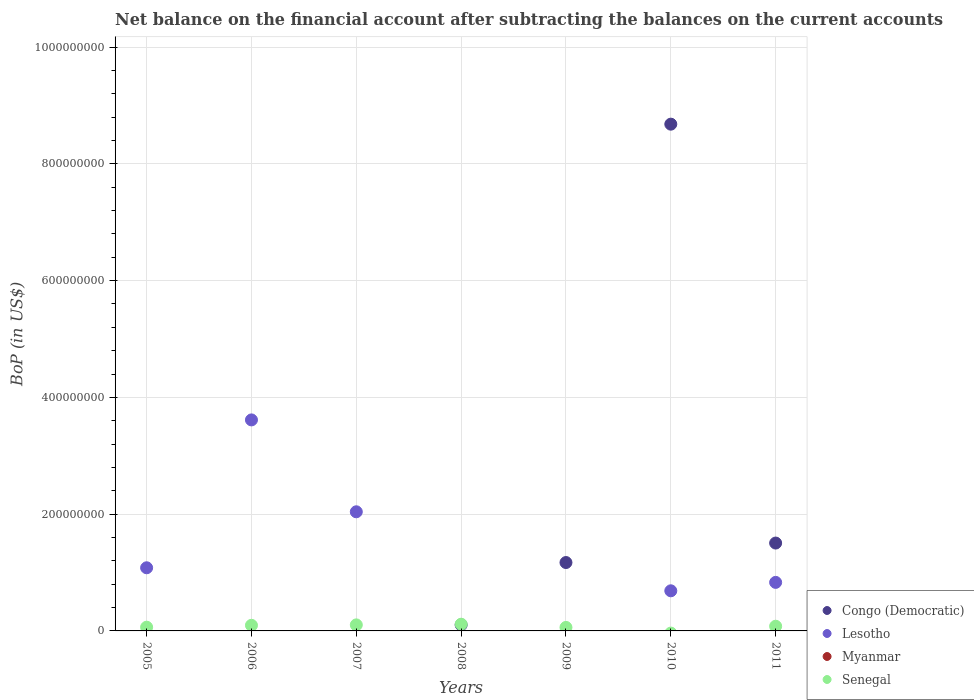How many different coloured dotlines are there?
Give a very brief answer. 3. Is the number of dotlines equal to the number of legend labels?
Your response must be concise. No. What is the Balance of Payments in Myanmar in 2008?
Offer a terse response. 0. Across all years, what is the maximum Balance of Payments in Senegal?
Provide a short and direct response. 1.15e+07. Across all years, what is the minimum Balance of Payments in Congo (Democratic)?
Keep it short and to the point. 0. In which year was the Balance of Payments in Congo (Democratic) maximum?
Provide a short and direct response. 2010. What is the total Balance of Payments in Myanmar in the graph?
Your response must be concise. 0. What is the difference between the Balance of Payments in Senegal in 2006 and that in 2011?
Your answer should be very brief. 1.59e+06. What is the difference between the Balance of Payments in Lesotho in 2011 and the Balance of Payments in Myanmar in 2009?
Offer a very short reply. 8.31e+07. What is the average Balance of Payments in Senegal per year?
Ensure brevity in your answer.  7.41e+06. In the year 2009, what is the difference between the Balance of Payments in Senegal and Balance of Payments in Congo (Democratic)?
Your answer should be very brief. -1.11e+08. In how many years, is the Balance of Payments in Congo (Democratic) greater than 400000000 US$?
Provide a succinct answer. 1. What is the difference between the highest and the second highest Balance of Payments in Senegal?
Provide a succinct answer. 1.15e+06. What is the difference between the highest and the lowest Balance of Payments in Senegal?
Ensure brevity in your answer.  1.15e+07. In how many years, is the Balance of Payments in Myanmar greater than the average Balance of Payments in Myanmar taken over all years?
Offer a terse response. 0. Is the sum of the Balance of Payments in Lesotho in 2007 and 2010 greater than the maximum Balance of Payments in Myanmar across all years?
Keep it short and to the point. Yes. Is the Balance of Payments in Lesotho strictly greater than the Balance of Payments in Myanmar over the years?
Your answer should be very brief. Yes. How many dotlines are there?
Provide a succinct answer. 3. How many years are there in the graph?
Offer a very short reply. 7. What is the difference between two consecutive major ticks on the Y-axis?
Give a very brief answer. 2.00e+08. What is the title of the graph?
Your answer should be compact. Net balance on the financial account after subtracting the balances on the current accounts. What is the label or title of the Y-axis?
Your response must be concise. BoP (in US$). What is the BoP (in US$) of Congo (Democratic) in 2005?
Give a very brief answer. 0. What is the BoP (in US$) of Lesotho in 2005?
Ensure brevity in your answer.  1.08e+08. What is the BoP (in US$) of Myanmar in 2005?
Make the answer very short. 0. What is the BoP (in US$) in Senegal in 2005?
Ensure brevity in your answer.  6.39e+06. What is the BoP (in US$) of Congo (Democratic) in 2006?
Give a very brief answer. 0. What is the BoP (in US$) in Lesotho in 2006?
Provide a short and direct response. 3.61e+08. What is the BoP (in US$) of Myanmar in 2006?
Your answer should be very brief. 0. What is the BoP (in US$) of Senegal in 2006?
Your answer should be compact. 9.62e+06. What is the BoP (in US$) in Lesotho in 2007?
Your response must be concise. 2.04e+08. What is the BoP (in US$) of Myanmar in 2007?
Make the answer very short. 0. What is the BoP (in US$) of Senegal in 2007?
Offer a very short reply. 1.03e+07. What is the BoP (in US$) of Congo (Democratic) in 2008?
Your answer should be very brief. 1.03e+07. What is the BoP (in US$) in Myanmar in 2008?
Your response must be concise. 0. What is the BoP (in US$) in Senegal in 2008?
Your answer should be compact. 1.15e+07. What is the BoP (in US$) in Congo (Democratic) in 2009?
Provide a short and direct response. 1.17e+08. What is the BoP (in US$) in Lesotho in 2009?
Keep it short and to the point. 0. What is the BoP (in US$) of Senegal in 2009?
Give a very brief answer. 5.99e+06. What is the BoP (in US$) of Congo (Democratic) in 2010?
Provide a succinct answer. 8.68e+08. What is the BoP (in US$) in Lesotho in 2010?
Provide a short and direct response. 6.87e+07. What is the BoP (in US$) in Myanmar in 2010?
Your answer should be very brief. 0. What is the BoP (in US$) of Senegal in 2010?
Offer a very short reply. 0. What is the BoP (in US$) in Congo (Democratic) in 2011?
Provide a succinct answer. 1.50e+08. What is the BoP (in US$) in Lesotho in 2011?
Your answer should be very brief. 8.31e+07. What is the BoP (in US$) of Senegal in 2011?
Your answer should be very brief. 8.03e+06. Across all years, what is the maximum BoP (in US$) in Congo (Democratic)?
Provide a succinct answer. 8.68e+08. Across all years, what is the maximum BoP (in US$) in Lesotho?
Your response must be concise. 3.61e+08. Across all years, what is the maximum BoP (in US$) of Senegal?
Your answer should be very brief. 1.15e+07. Across all years, what is the minimum BoP (in US$) in Lesotho?
Your answer should be very brief. 0. What is the total BoP (in US$) of Congo (Democratic) in the graph?
Offer a terse response. 1.15e+09. What is the total BoP (in US$) of Lesotho in the graph?
Your response must be concise. 8.25e+08. What is the total BoP (in US$) in Myanmar in the graph?
Offer a terse response. 0. What is the total BoP (in US$) in Senegal in the graph?
Provide a succinct answer. 5.19e+07. What is the difference between the BoP (in US$) of Lesotho in 2005 and that in 2006?
Your answer should be compact. -2.53e+08. What is the difference between the BoP (in US$) of Senegal in 2005 and that in 2006?
Your response must be concise. -3.23e+06. What is the difference between the BoP (in US$) in Lesotho in 2005 and that in 2007?
Provide a short and direct response. -9.59e+07. What is the difference between the BoP (in US$) in Senegal in 2005 and that in 2007?
Make the answer very short. -3.96e+06. What is the difference between the BoP (in US$) of Senegal in 2005 and that in 2008?
Make the answer very short. -5.11e+06. What is the difference between the BoP (in US$) of Senegal in 2005 and that in 2009?
Keep it short and to the point. 3.96e+05. What is the difference between the BoP (in US$) in Lesotho in 2005 and that in 2010?
Provide a short and direct response. 3.94e+07. What is the difference between the BoP (in US$) of Lesotho in 2005 and that in 2011?
Provide a short and direct response. 2.50e+07. What is the difference between the BoP (in US$) in Senegal in 2005 and that in 2011?
Offer a very short reply. -1.64e+06. What is the difference between the BoP (in US$) in Lesotho in 2006 and that in 2007?
Offer a terse response. 1.57e+08. What is the difference between the BoP (in US$) in Senegal in 2006 and that in 2007?
Offer a terse response. -7.30e+05. What is the difference between the BoP (in US$) in Senegal in 2006 and that in 2008?
Offer a very short reply. -1.88e+06. What is the difference between the BoP (in US$) in Senegal in 2006 and that in 2009?
Make the answer very short. 3.63e+06. What is the difference between the BoP (in US$) in Lesotho in 2006 and that in 2010?
Your answer should be very brief. 2.93e+08. What is the difference between the BoP (in US$) of Lesotho in 2006 and that in 2011?
Your response must be concise. 2.78e+08. What is the difference between the BoP (in US$) of Senegal in 2006 and that in 2011?
Offer a very short reply. 1.59e+06. What is the difference between the BoP (in US$) in Senegal in 2007 and that in 2008?
Ensure brevity in your answer.  -1.15e+06. What is the difference between the BoP (in US$) of Senegal in 2007 and that in 2009?
Ensure brevity in your answer.  4.36e+06. What is the difference between the BoP (in US$) in Lesotho in 2007 and that in 2010?
Keep it short and to the point. 1.35e+08. What is the difference between the BoP (in US$) in Lesotho in 2007 and that in 2011?
Ensure brevity in your answer.  1.21e+08. What is the difference between the BoP (in US$) of Senegal in 2007 and that in 2011?
Keep it short and to the point. 2.32e+06. What is the difference between the BoP (in US$) of Congo (Democratic) in 2008 and that in 2009?
Keep it short and to the point. -1.07e+08. What is the difference between the BoP (in US$) in Senegal in 2008 and that in 2009?
Your response must be concise. 5.51e+06. What is the difference between the BoP (in US$) of Congo (Democratic) in 2008 and that in 2010?
Give a very brief answer. -8.58e+08. What is the difference between the BoP (in US$) in Congo (Democratic) in 2008 and that in 2011?
Your answer should be very brief. -1.40e+08. What is the difference between the BoP (in US$) of Senegal in 2008 and that in 2011?
Your answer should be very brief. 3.47e+06. What is the difference between the BoP (in US$) in Congo (Democratic) in 2009 and that in 2010?
Provide a succinct answer. -7.51e+08. What is the difference between the BoP (in US$) in Congo (Democratic) in 2009 and that in 2011?
Your answer should be very brief. -3.34e+07. What is the difference between the BoP (in US$) of Senegal in 2009 and that in 2011?
Give a very brief answer. -2.04e+06. What is the difference between the BoP (in US$) in Congo (Democratic) in 2010 and that in 2011?
Give a very brief answer. 7.17e+08. What is the difference between the BoP (in US$) in Lesotho in 2010 and that in 2011?
Provide a short and direct response. -1.44e+07. What is the difference between the BoP (in US$) in Lesotho in 2005 and the BoP (in US$) in Senegal in 2006?
Give a very brief answer. 9.85e+07. What is the difference between the BoP (in US$) in Lesotho in 2005 and the BoP (in US$) in Senegal in 2007?
Offer a very short reply. 9.78e+07. What is the difference between the BoP (in US$) in Lesotho in 2005 and the BoP (in US$) in Senegal in 2008?
Provide a short and direct response. 9.66e+07. What is the difference between the BoP (in US$) of Lesotho in 2005 and the BoP (in US$) of Senegal in 2009?
Offer a terse response. 1.02e+08. What is the difference between the BoP (in US$) in Lesotho in 2005 and the BoP (in US$) in Senegal in 2011?
Make the answer very short. 1.00e+08. What is the difference between the BoP (in US$) in Lesotho in 2006 and the BoP (in US$) in Senegal in 2007?
Provide a succinct answer. 3.51e+08. What is the difference between the BoP (in US$) of Lesotho in 2006 and the BoP (in US$) of Senegal in 2008?
Keep it short and to the point. 3.50e+08. What is the difference between the BoP (in US$) in Lesotho in 2006 and the BoP (in US$) in Senegal in 2009?
Your answer should be compact. 3.55e+08. What is the difference between the BoP (in US$) in Lesotho in 2006 and the BoP (in US$) in Senegal in 2011?
Ensure brevity in your answer.  3.53e+08. What is the difference between the BoP (in US$) of Lesotho in 2007 and the BoP (in US$) of Senegal in 2008?
Offer a very short reply. 1.93e+08. What is the difference between the BoP (in US$) in Lesotho in 2007 and the BoP (in US$) in Senegal in 2009?
Give a very brief answer. 1.98e+08. What is the difference between the BoP (in US$) in Lesotho in 2007 and the BoP (in US$) in Senegal in 2011?
Offer a terse response. 1.96e+08. What is the difference between the BoP (in US$) of Congo (Democratic) in 2008 and the BoP (in US$) of Senegal in 2009?
Provide a succinct answer. 4.31e+06. What is the difference between the BoP (in US$) of Congo (Democratic) in 2008 and the BoP (in US$) of Lesotho in 2010?
Offer a terse response. -5.84e+07. What is the difference between the BoP (in US$) in Congo (Democratic) in 2008 and the BoP (in US$) in Lesotho in 2011?
Make the answer very short. -7.28e+07. What is the difference between the BoP (in US$) of Congo (Democratic) in 2008 and the BoP (in US$) of Senegal in 2011?
Provide a short and direct response. 2.27e+06. What is the difference between the BoP (in US$) of Congo (Democratic) in 2009 and the BoP (in US$) of Lesotho in 2010?
Offer a terse response. 4.84e+07. What is the difference between the BoP (in US$) in Congo (Democratic) in 2009 and the BoP (in US$) in Lesotho in 2011?
Provide a short and direct response. 3.40e+07. What is the difference between the BoP (in US$) in Congo (Democratic) in 2009 and the BoP (in US$) in Senegal in 2011?
Provide a short and direct response. 1.09e+08. What is the difference between the BoP (in US$) of Congo (Democratic) in 2010 and the BoP (in US$) of Lesotho in 2011?
Keep it short and to the point. 7.85e+08. What is the difference between the BoP (in US$) in Congo (Democratic) in 2010 and the BoP (in US$) in Senegal in 2011?
Provide a short and direct response. 8.60e+08. What is the difference between the BoP (in US$) in Lesotho in 2010 and the BoP (in US$) in Senegal in 2011?
Your answer should be compact. 6.07e+07. What is the average BoP (in US$) of Congo (Democratic) per year?
Provide a succinct answer. 1.64e+08. What is the average BoP (in US$) of Lesotho per year?
Your answer should be compact. 1.18e+08. What is the average BoP (in US$) in Senegal per year?
Your answer should be compact. 7.41e+06. In the year 2005, what is the difference between the BoP (in US$) of Lesotho and BoP (in US$) of Senegal?
Your answer should be compact. 1.02e+08. In the year 2006, what is the difference between the BoP (in US$) in Lesotho and BoP (in US$) in Senegal?
Your answer should be very brief. 3.52e+08. In the year 2007, what is the difference between the BoP (in US$) of Lesotho and BoP (in US$) of Senegal?
Offer a terse response. 1.94e+08. In the year 2008, what is the difference between the BoP (in US$) in Congo (Democratic) and BoP (in US$) in Senegal?
Make the answer very short. -1.20e+06. In the year 2009, what is the difference between the BoP (in US$) of Congo (Democratic) and BoP (in US$) of Senegal?
Offer a terse response. 1.11e+08. In the year 2010, what is the difference between the BoP (in US$) in Congo (Democratic) and BoP (in US$) in Lesotho?
Your answer should be very brief. 7.99e+08. In the year 2011, what is the difference between the BoP (in US$) in Congo (Democratic) and BoP (in US$) in Lesotho?
Your response must be concise. 6.74e+07. In the year 2011, what is the difference between the BoP (in US$) of Congo (Democratic) and BoP (in US$) of Senegal?
Your answer should be compact. 1.42e+08. In the year 2011, what is the difference between the BoP (in US$) of Lesotho and BoP (in US$) of Senegal?
Ensure brevity in your answer.  7.51e+07. What is the ratio of the BoP (in US$) in Lesotho in 2005 to that in 2006?
Provide a succinct answer. 0.3. What is the ratio of the BoP (in US$) of Senegal in 2005 to that in 2006?
Offer a terse response. 0.66. What is the ratio of the BoP (in US$) in Lesotho in 2005 to that in 2007?
Your answer should be very brief. 0.53. What is the ratio of the BoP (in US$) in Senegal in 2005 to that in 2007?
Offer a very short reply. 0.62. What is the ratio of the BoP (in US$) of Senegal in 2005 to that in 2008?
Ensure brevity in your answer.  0.56. What is the ratio of the BoP (in US$) of Senegal in 2005 to that in 2009?
Offer a terse response. 1.07. What is the ratio of the BoP (in US$) in Lesotho in 2005 to that in 2010?
Keep it short and to the point. 1.57. What is the ratio of the BoP (in US$) in Lesotho in 2005 to that in 2011?
Offer a terse response. 1.3. What is the ratio of the BoP (in US$) of Senegal in 2005 to that in 2011?
Give a very brief answer. 0.8. What is the ratio of the BoP (in US$) of Lesotho in 2006 to that in 2007?
Ensure brevity in your answer.  1.77. What is the ratio of the BoP (in US$) of Senegal in 2006 to that in 2007?
Your answer should be very brief. 0.93. What is the ratio of the BoP (in US$) in Senegal in 2006 to that in 2008?
Give a very brief answer. 0.84. What is the ratio of the BoP (in US$) in Senegal in 2006 to that in 2009?
Your answer should be very brief. 1.6. What is the ratio of the BoP (in US$) of Lesotho in 2006 to that in 2010?
Provide a short and direct response. 5.26. What is the ratio of the BoP (in US$) of Lesotho in 2006 to that in 2011?
Give a very brief answer. 4.35. What is the ratio of the BoP (in US$) of Senegal in 2006 to that in 2011?
Provide a short and direct response. 1.2. What is the ratio of the BoP (in US$) in Senegal in 2007 to that in 2008?
Your answer should be very brief. 0.9. What is the ratio of the BoP (in US$) in Senegal in 2007 to that in 2009?
Your answer should be very brief. 1.73. What is the ratio of the BoP (in US$) of Lesotho in 2007 to that in 2010?
Give a very brief answer. 2.97. What is the ratio of the BoP (in US$) of Lesotho in 2007 to that in 2011?
Give a very brief answer. 2.45. What is the ratio of the BoP (in US$) in Senegal in 2007 to that in 2011?
Your answer should be compact. 1.29. What is the ratio of the BoP (in US$) of Congo (Democratic) in 2008 to that in 2009?
Your answer should be very brief. 0.09. What is the ratio of the BoP (in US$) of Senegal in 2008 to that in 2009?
Offer a very short reply. 1.92. What is the ratio of the BoP (in US$) of Congo (Democratic) in 2008 to that in 2010?
Keep it short and to the point. 0.01. What is the ratio of the BoP (in US$) of Congo (Democratic) in 2008 to that in 2011?
Ensure brevity in your answer.  0.07. What is the ratio of the BoP (in US$) of Senegal in 2008 to that in 2011?
Give a very brief answer. 1.43. What is the ratio of the BoP (in US$) in Congo (Democratic) in 2009 to that in 2010?
Your response must be concise. 0.14. What is the ratio of the BoP (in US$) in Congo (Democratic) in 2009 to that in 2011?
Give a very brief answer. 0.78. What is the ratio of the BoP (in US$) of Senegal in 2009 to that in 2011?
Your response must be concise. 0.75. What is the ratio of the BoP (in US$) in Congo (Democratic) in 2010 to that in 2011?
Provide a succinct answer. 5.77. What is the ratio of the BoP (in US$) in Lesotho in 2010 to that in 2011?
Provide a succinct answer. 0.83. What is the difference between the highest and the second highest BoP (in US$) in Congo (Democratic)?
Your response must be concise. 7.17e+08. What is the difference between the highest and the second highest BoP (in US$) in Lesotho?
Your response must be concise. 1.57e+08. What is the difference between the highest and the second highest BoP (in US$) of Senegal?
Keep it short and to the point. 1.15e+06. What is the difference between the highest and the lowest BoP (in US$) of Congo (Democratic)?
Provide a short and direct response. 8.68e+08. What is the difference between the highest and the lowest BoP (in US$) in Lesotho?
Offer a terse response. 3.61e+08. What is the difference between the highest and the lowest BoP (in US$) of Senegal?
Your answer should be very brief. 1.15e+07. 